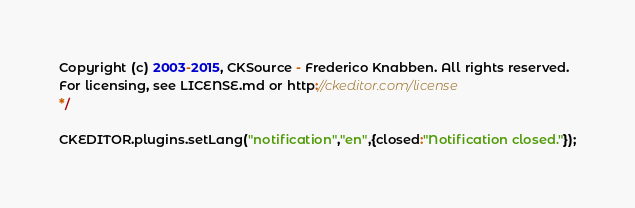<code> <loc_0><loc_0><loc_500><loc_500><_JavaScript_>Copyright (c) 2003-2015, CKSource - Frederico Knabben. All rights reserved.
For licensing, see LICENSE.md or http://ckeditor.com/license
*/

CKEDITOR.plugins.setLang("notification","en",{closed:"Notification closed."});</code> 